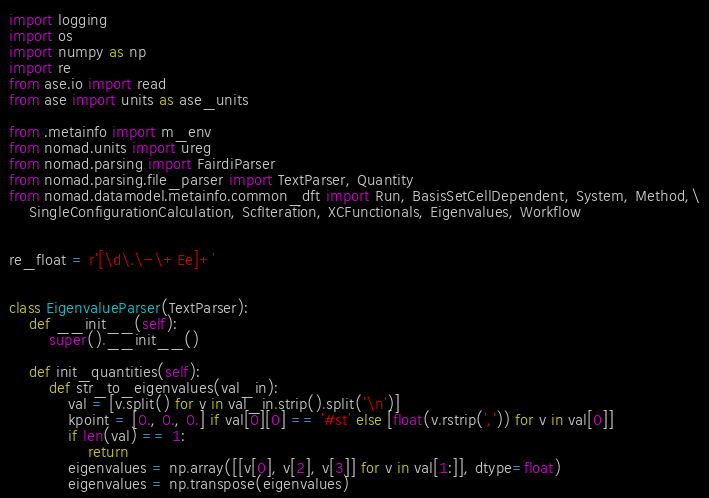Convert code to text. <code><loc_0><loc_0><loc_500><loc_500><_Python_>import logging
import os
import numpy as np
import re
from ase.io import read
from ase import units as ase_units

from .metainfo import m_env
from nomad.units import ureg
from nomad.parsing import FairdiParser
from nomad.parsing.file_parser import TextParser, Quantity
from nomad.datamodel.metainfo.common_dft import Run, BasisSetCellDependent, System, Method,\
    SingleConfigurationCalculation, ScfIteration, XCFunctionals, Eigenvalues, Workflow


re_float = r'[\d\.\-\+Ee]+'


class EigenvalueParser(TextParser):
    def __init__(self):
        super().__init__()

    def init_quantities(self):
        def str_to_eigenvalues(val_in):
            val = [v.split() for v in val_in.strip().split('\n')]
            kpoint = [0., 0., 0.] if val[0][0] == '#st' else [float(v.rstrip(',')) for v in val[0]]
            if len(val) == 1:
                return
            eigenvalues = np.array([[v[0], v[2], v[3]] for v in val[1:]], dtype=float)
            eigenvalues = np.transpose(eigenvalues)</code> 